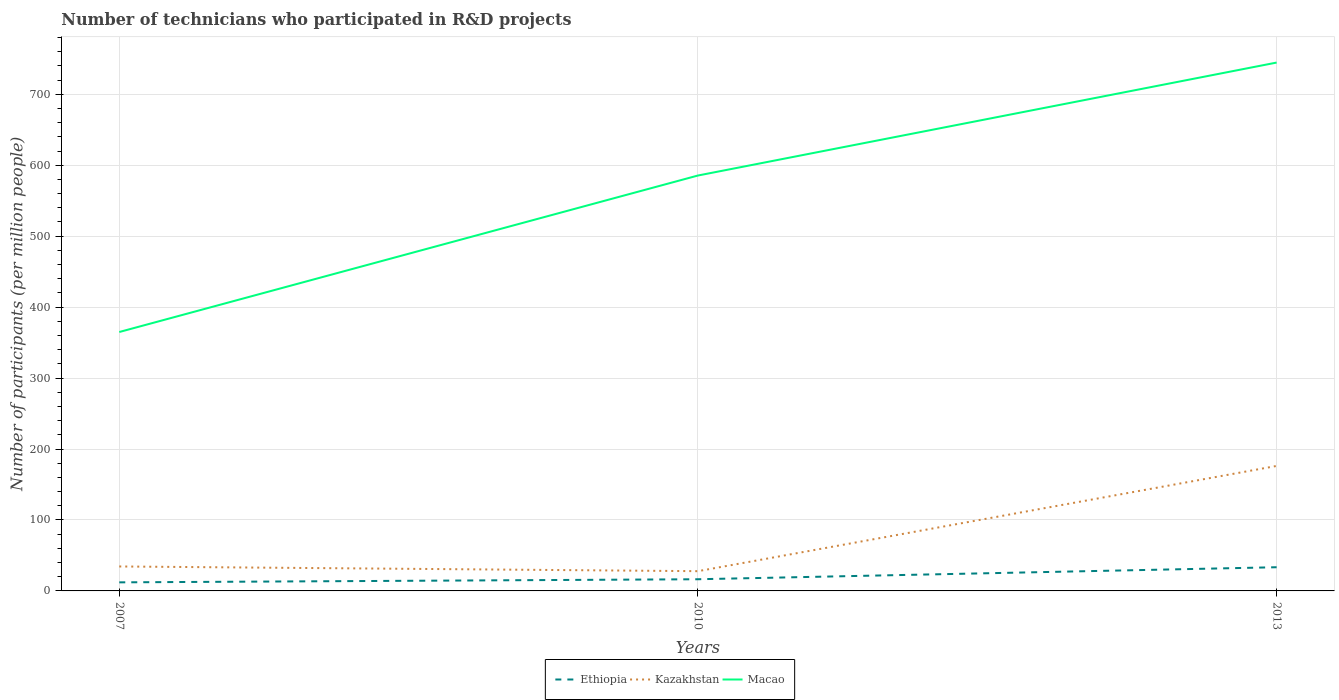How many different coloured lines are there?
Make the answer very short. 3. Across all years, what is the maximum number of technicians who participated in R&D projects in Macao?
Your response must be concise. 364.89. What is the total number of technicians who participated in R&D projects in Kazakhstan in the graph?
Your answer should be very brief. 6.63. What is the difference between the highest and the second highest number of technicians who participated in R&D projects in Ethiopia?
Your answer should be compact. 21.29. What is the difference between the highest and the lowest number of technicians who participated in R&D projects in Macao?
Offer a terse response. 2. Is the number of technicians who participated in R&D projects in Ethiopia strictly greater than the number of technicians who participated in R&D projects in Kazakhstan over the years?
Your response must be concise. Yes. How many lines are there?
Provide a short and direct response. 3. How many years are there in the graph?
Your response must be concise. 3. Are the values on the major ticks of Y-axis written in scientific E-notation?
Provide a succinct answer. No. Where does the legend appear in the graph?
Offer a very short reply. Bottom center. How many legend labels are there?
Make the answer very short. 3. How are the legend labels stacked?
Offer a very short reply. Horizontal. What is the title of the graph?
Offer a very short reply. Number of technicians who participated in R&D projects. Does "Least developed countries" appear as one of the legend labels in the graph?
Ensure brevity in your answer.  No. What is the label or title of the X-axis?
Ensure brevity in your answer.  Years. What is the label or title of the Y-axis?
Make the answer very short. Number of participants (per million people). What is the Number of participants (per million people) in Ethiopia in 2007?
Offer a terse response. 12.09. What is the Number of participants (per million people) in Kazakhstan in 2007?
Keep it short and to the point. 34.46. What is the Number of participants (per million people) of Macao in 2007?
Ensure brevity in your answer.  364.89. What is the Number of participants (per million people) in Ethiopia in 2010?
Your response must be concise. 16.46. What is the Number of participants (per million people) of Kazakhstan in 2010?
Your answer should be very brief. 27.83. What is the Number of participants (per million people) of Macao in 2010?
Offer a terse response. 585.46. What is the Number of participants (per million people) of Ethiopia in 2013?
Give a very brief answer. 33.38. What is the Number of participants (per million people) in Kazakhstan in 2013?
Provide a short and direct response. 176.15. What is the Number of participants (per million people) of Macao in 2013?
Keep it short and to the point. 744.64. Across all years, what is the maximum Number of participants (per million people) in Ethiopia?
Your answer should be compact. 33.38. Across all years, what is the maximum Number of participants (per million people) in Kazakhstan?
Your answer should be very brief. 176.15. Across all years, what is the maximum Number of participants (per million people) of Macao?
Give a very brief answer. 744.64. Across all years, what is the minimum Number of participants (per million people) in Ethiopia?
Keep it short and to the point. 12.09. Across all years, what is the minimum Number of participants (per million people) in Kazakhstan?
Give a very brief answer. 27.83. Across all years, what is the minimum Number of participants (per million people) of Macao?
Provide a short and direct response. 364.89. What is the total Number of participants (per million people) of Ethiopia in the graph?
Your answer should be very brief. 61.93. What is the total Number of participants (per million people) of Kazakhstan in the graph?
Your response must be concise. 238.44. What is the total Number of participants (per million people) of Macao in the graph?
Make the answer very short. 1694.99. What is the difference between the Number of participants (per million people) in Ethiopia in 2007 and that in 2010?
Offer a terse response. -4.37. What is the difference between the Number of participants (per million people) of Kazakhstan in 2007 and that in 2010?
Your answer should be very brief. 6.63. What is the difference between the Number of participants (per million people) of Macao in 2007 and that in 2010?
Offer a very short reply. -220.56. What is the difference between the Number of participants (per million people) in Ethiopia in 2007 and that in 2013?
Offer a very short reply. -21.29. What is the difference between the Number of participants (per million people) in Kazakhstan in 2007 and that in 2013?
Offer a very short reply. -141.68. What is the difference between the Number of participants (per million people) in Macao in 2007 and that in 2013?
Provide a short and direct response. -379.75. What is the difference between the Number of participants (per million people) of Ethiopia in 2010 and that in 2013?
Provide a short and direct response. -16.93. What is the difference between the Number of participants (per million people) of Kazakhstan in 2010 and that in 2013?
Offer a terse response. -148.31. What is the difference between the Number of participants (per million people) in Macao in 2010 and that in 2013?
Offer a very short reply. -159.19. What is the difference between the Number of participants (per million people) of Ethiopia in 2007 and the Number of participants (per million people) of Kazakhstan in 2010?
Make the answer very short. -15.74. What is the difference between the Number of participants (per million people) in Ethiopia in 2007 and the Number of participants (per million people) in Macao in 2010?
Provide a succinct answer. -573.37. What is the difference between the Number of participants (per million people) in Kazakhstan in 2007 and the Number of participants (per million people) in Macao in 2010?
Give a very brief answer. -550.99. What is the difference between the Number of participants (per million people) in Ethiopia in 2007 and the Number of participants (per million people) in Kazakhstan in 2013?
Keep it short and to the point. -164.05. What is the difference between the Number of participants (per million people) of Ethiopia in 2007 and the Number of participants (per million people) of Macao in 2013?
Give a very brief answer. -732.55. What is the difference between the Number of participants (per million people) of Kazakhstan in 2007 and the Number of participants (per million people) of Macao in 2013?
Keep it short and to the point. -710.18. What is the difference between the Number of participants (per million people) of Ethiopia in 2010 and the Number of participants (per million people) of Kazakhstan in 2013?
Your answer should be compact. -159.69. What is the difference between the Number of participants (per million people) of Ethiopia in 2010 and the Number of participants (per million people) of Macao in 2013?
Ensure brevity in your answer.  -728.19. What is the difference between the Number of participants (per million people) of Kazakhstan in 2010 and the Number of participants (per million people) of Macao in 2013?
Ensure brevity in your answer.  -716.81. What is the average Number of participants (per million people) of Ethiopia per year?
Your answer should be compact. 20.64. What is the average Number of participants (per million people) of Kazakhstan per year?
Offer a very short reply. 79.48. What is the average Number of participants (per million people) in Macao per year?
Make the answer very short. 565. In the year 2007, what is the difference between the Number of participants (per million people) in Ethiopia and Number of participants (per million people) in Kazakhstan?
Ensure brevity in your answer.  -22.37. In the year 2007, what is the difference between the Number of participants (per million people) in Ethiopia and Number of participants (per million people) in Macao?
Provide a short and direct response. -352.8. In the year 2007, what is the difference between the Number of participants (per million people) of Kazakhstan and Number of participants (per million people) of Macao?
Ensure brevity in your answer.  -330.43. In the year 2010, what is the difference between the Number of participants (per million people) in Ethiopia and Number of participants (per million people) in Kazakhstan?
Offer a very short reply. -11.38. In the year 2010, what is the difference between the Number of participants (per million people) of Ethiopia and Number of participants (per million people) of Macao?
Provide a succinct answer. -569. In the year 2010, what is the difference between the Number of participants (per million people) in Kazakhstan and Number of participants (per million people) in Macao?
Provide a succinct answer. -557.62. In the year 2013, what is the difference between the Number of participants (per million people) in Ethiopia and Number of participants (per million people) in Kazakhstan?
Your response must be concise. -142.76. In the year 2013, what is the difference between the Number of participants (per million people) of Ethiopia and Number of participants (per million people) of Macao?
Provide a succinct answer. -711.26. In the year 2013, what is the difference between the Number of participants (per million people) in Kazakhstan and Number of participants (per million people) in Macao?
Offer a very short reply. -568.5. What is the ratio of the Number of participants (per million people) of Ethiopia in 2007 to that in 2010?
Provide a short and direct response. 0.73. What is the ratio of the Number of participants (per million people) in Kazakhstan in 2007 to that in 2010?
Provide a succinct answer. 1.24. What is the ratio of the Number of participants (per million people) in Macao in 2007 to that in 2010?
Keep it short and to the point. 0.62. What is the ratio of the Number of participants (per million people) of Ethiopia in 2007 to that in 2013?
Offer a very short reply. 0.36. What is the ratio of the Number of participants (per million people) of Kazakhstan in 2007 to that in 2013?
Your response must be concise. 0.2. What is the ratio of the Number of participants (per million people) in Macao in 2007 to that in 2013?
Keep it short and to the point. 0.49. What is the ratio of the Number of participants (per million people) of Ethiopia in 2010 to that in 2013?
Provide a succinct answer. 0.49. What is the ratio of the Number of participants (per million people) in Kazakhstan in 2010 to that in 2013?
Ensure brevity in your answer.  0.16. What is the ratio of the Number of participants (per million people) of Macao in 2010 to that in 2013?
Offer a very short reply. 0.79. What is the difference between the highest and the second highest Number of participants (per million people) of Ethiopia?
Provide a short and direct response. 16.93. What is the difference between the highest and the second highest Number of participants (per million people) of Kazakhstan?
Your answer should be very brief. 141.68. What is the difference between the highest and the second highest Number of participants (per million people) in Macao?
Make the answer very short. 159.19. What is the difference between the highest and the lowest Number of participants (per million people) in Ethiopia?
Give a very brief answer. 21.29. What is the difference between the highest and the lowest Number of participants (per million people) in Kazakhstan?
Your answer should be very brief. 148.31. What is the difference between the highest and the lowest Number of participants (per million people) in Macao?
Ensure brevity in your answer.  379.75. 